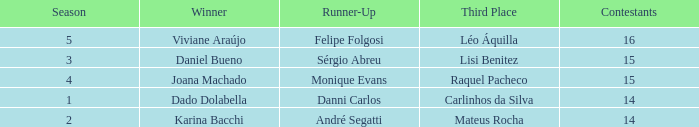Who was the winner when Mateus Rocha finished in 3rd place?  Karina Bacchi. 